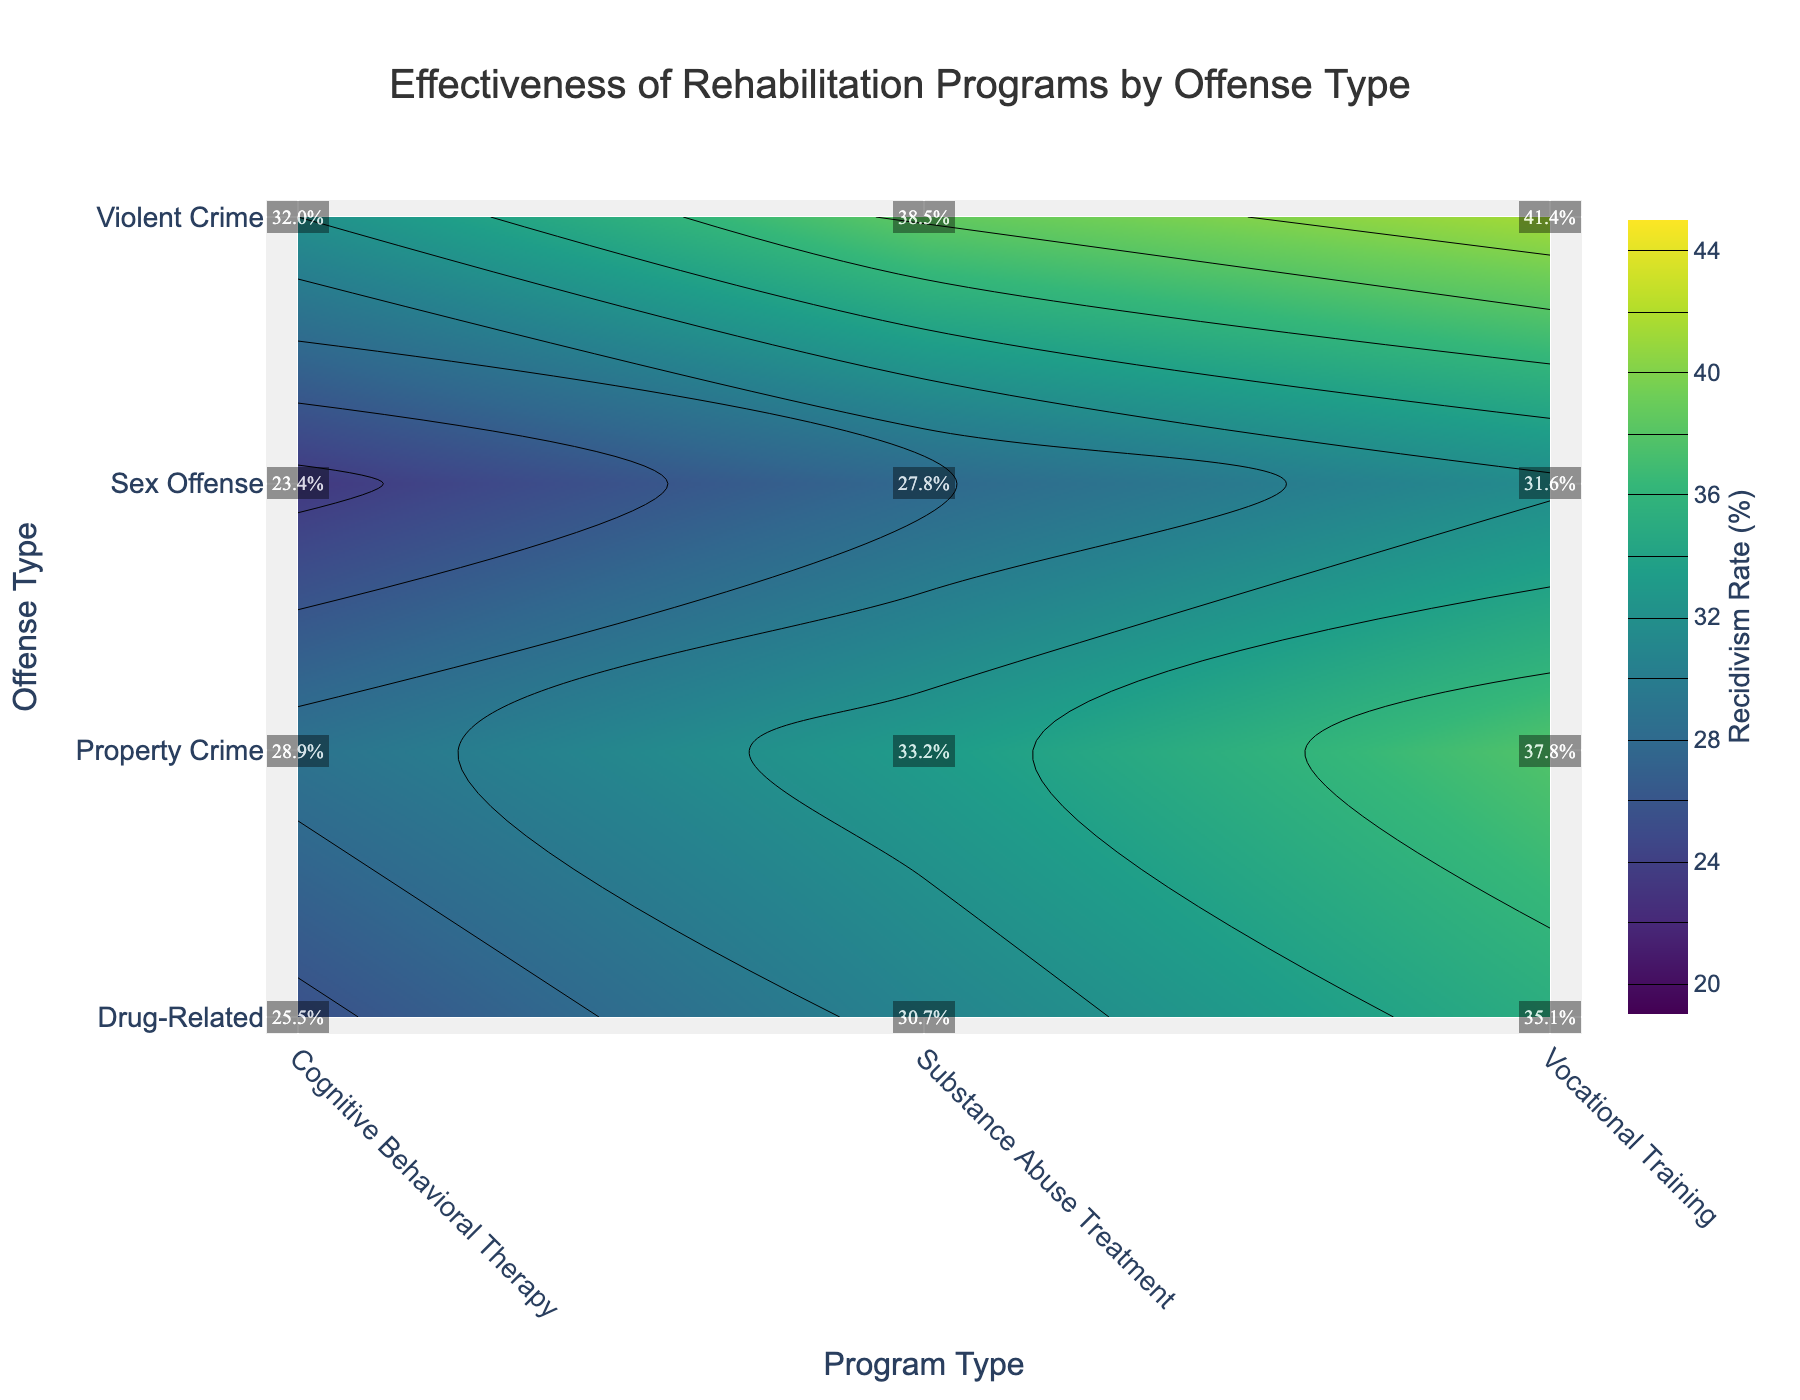What is the title of the figure? The title is usually displayed at the top of the figure. In this case, it reads, "Effectiveness of Rehabilitation Programs by Offense Type".
Answer: Effectiveness of Rehabilitation Programs by Offense Type What does the color bar represent? The color bar on the right side of the figure indicates the recidivism rate and its corresponding colors on the contour plot.
Answer: Recidivism Rate Which program type has the overall lowest recidivism rates across all offense types? By examining the colors and labels, we see that "Cognitive Behavioral Therapy" consistently has the lowest recidivism rates across different offense types compared to the other programs.
Answer: Cognitive Behavioral Therapy For drug-related offenses, what is the difference in recidivism rates between Cognitive Behavioral Therapy and Substance Abuse Treatment? The recidivism rate for Cognitive Behavioral Therapy is 25.5%, and for Substance Abuse Treatment, it is 30.7%. The difference is 30.7% - 25.5% = 5.2%.
Answer: 5.2% Which offense type has the highest recidivism rate for Vocational Training? Looking at the Vocational Training column, "Violent Crime" has the highest recidivism rate at 41.4%.
Answer: Violent Crime How does the recidivism rate vary for Substance Abuse Treatment across different offense types? For Substance Abuse Treatment, the recidivism rates are 30.7% (Drug-Related), 33.2% (Property Crime), 38.5% (Violent Crime), and 27.8% (Sex Offense). The rates fluctuate with the highest being for Violent Crime and the lowest for Sex Offense.
Answer: Varies from 27.8% to 38.5% In the context of sex offenses, which program type shows the lowest recidivism rate, and what is it? The lowest recidivism rate for sex offenses is found in Cognitive Behavioral Therapy, which is 23.4%.
Answer: Cognitive Behavioral Therapy, 23.4% What is the sum of recidivism rates for Property Crime across all program types? The recidivism rates for Property Crime are 28.9% (Cognitive Behavioral Therapy), 33.2% (Substance Abuse Treatment), and 37.8% (Vocational Training). Summing these gives 28.9 + 33.2 + 37.8 = 99.9%.
Answer: 99.9% What trends can you observe about recidivism rates and program effectiveness from the figure? Examining the contour plot and consulting the color gradients, we observe that Cognitive Behavioral Therapy tends to have the lowest recidivism rates across all offense types, followed by Substance Abuse Treatment and then Vocational Training.
Answer: Cognitive Behavioral Therapy is most effective, Vocational Training least effective 